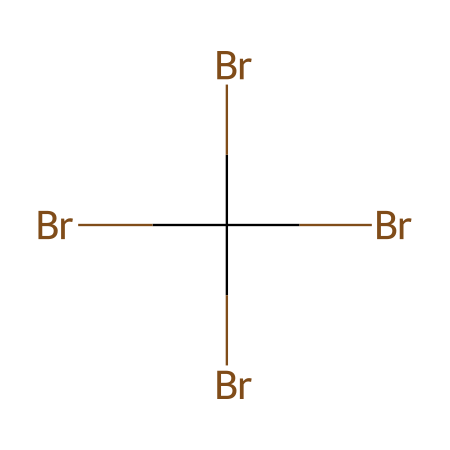What is the total number of bromine atoms in this structure? The given SMILES representation indicates four bromine (Br) atoms are present. Each 'Br' in the structure corresponds to one bromine atom, and since there are four 'Br' symbols listed, the total is four.
Answer: four How many carbon atoms are present in the chemical? The structure shows 'C' once in the SMILES, meaning there is one carbon atom in this compound. Since the representation includes only one 'C', the total number of carbon atoms is one.
Answer: one What is the chemical name of this compound? This compound, which has four bromine atoms attached to a single carbon atom, is known as tetrabromomethane. The prefix 'tetra' indicates the presence of four bromine substituents on the carbon atom.
Answer: tetrabromomethane How does the presence of multiple bromine atoms affect the chemical's properties? The multiple bromine atoms in this compound increase its effectiveness as a fire retardant due to their ability to release bromine radicals when heated, which helps to suppress combustion. The numerous bromine atoms enhance the overall stability and reactivity of the compound in fire-retardant applications.
Answer: increases fire retardancy Does this compound contain any hydrogen atoms? The structure indicates that all valences of the carbon are satisfied by bromine atoms. Since no hydrogen atoms are present in this arrangement (as all attachments are with bromine), the total number of hydrogen atoms is zero.
Answer: zero What type of reactions does tetrabromomethane undergo when exposed to heat? Tetrabromomethane can undergo thermal decomposition when heated, leading to the release of bromine gas and potentially contributing to free radical formation. This helps in disrupting combustion processes.
Answer: thermal decomposition 